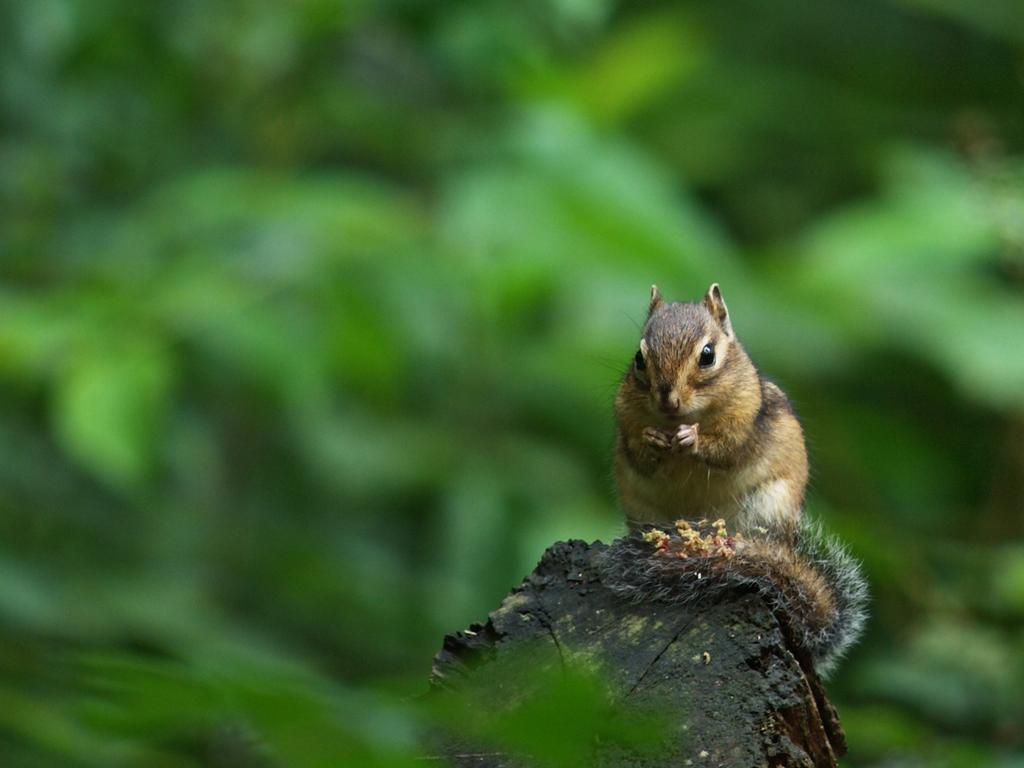What type of animal is in the image? There is a squirrel in the image. Where is the squirrel located? The squirrel is on a log. What type of watch is the squirrel wearing in the image? There is no watch present in the image; the squirrel is an animal and does not wear accessories. 